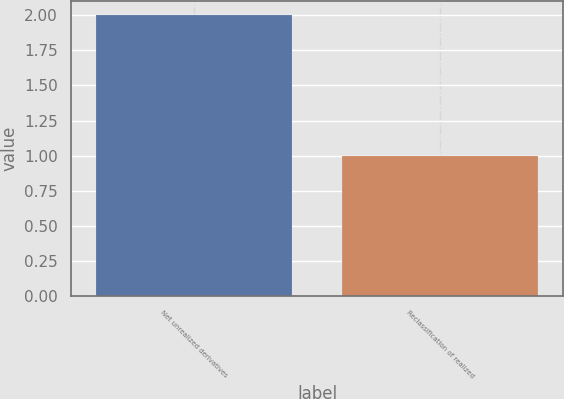<chart> <loc_0><loc_0><loc_500><loc_500><bar_chart><fcel>Net unrealized derivatives<fcel>Reclassification of realized<nl><fcel>2<fcel>1<nl></chart> 